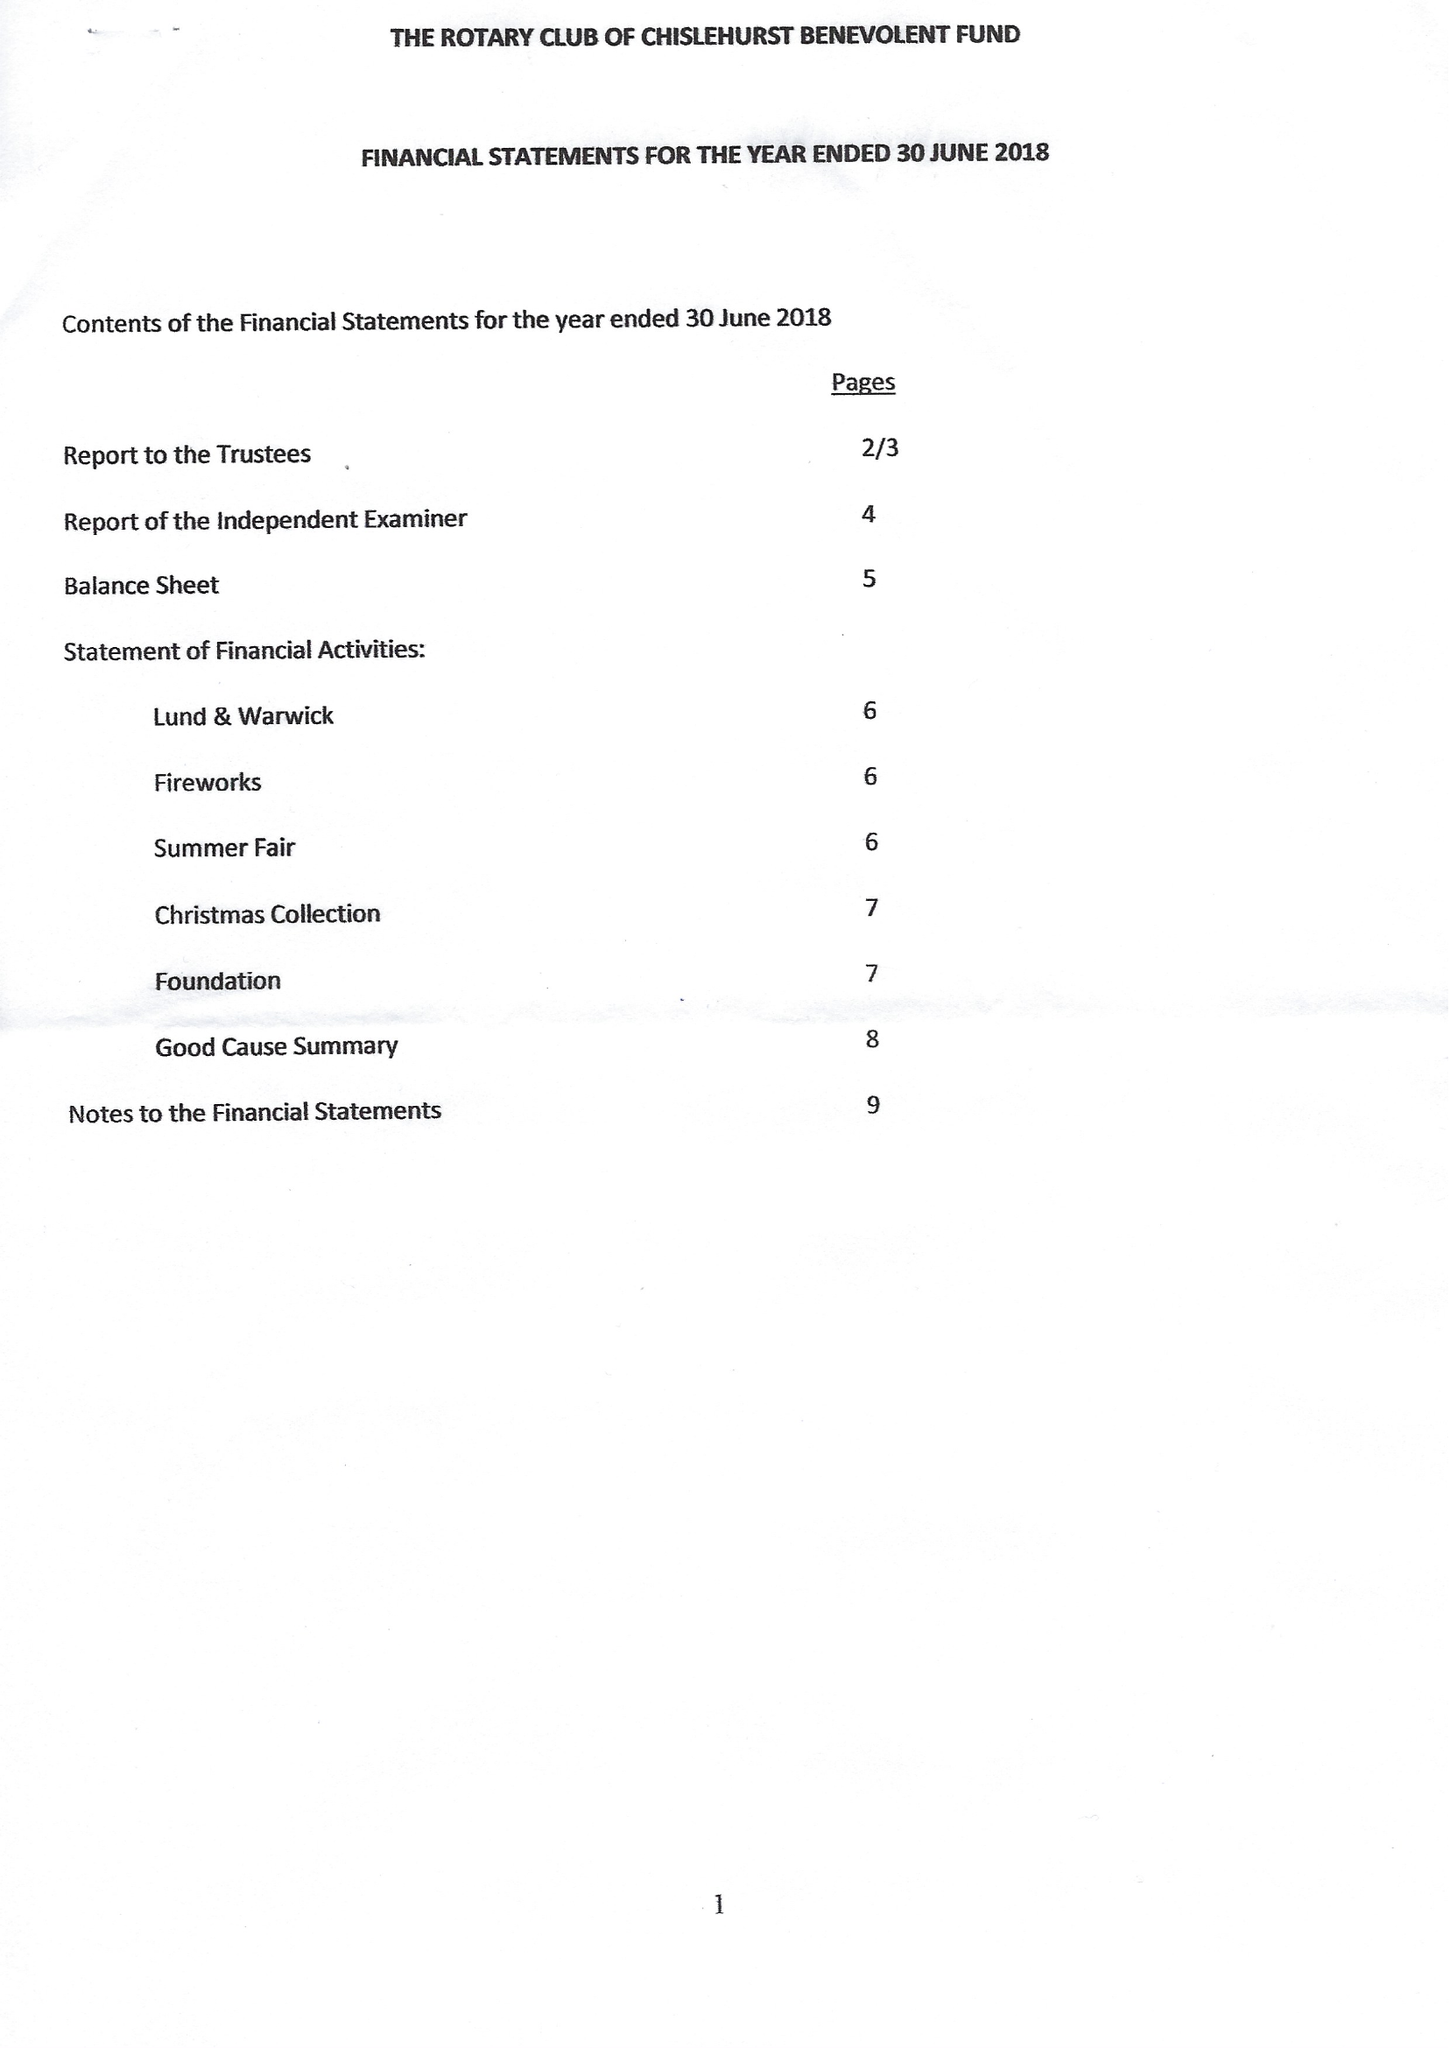What is the value for the income_annually_in_british_pounds?
Answer the question using a single word or phrase. 33232.00 